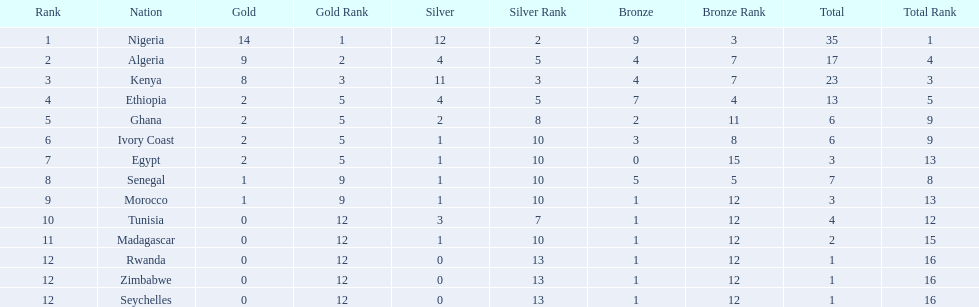What are all the nations? Nigeria, Algeria, Kenya, Ethiopia, Ghana, Ivory Coast, Egypt, Senegal, Morocco, Tunisia, Madagascar, Rwanda, Zimbabwe, Seychelles. How many bronze medals did they win? 9, 4, 4, 7, 2, 3, 0, 5, 1, 1, 1, 1, 1, 1. And which nation did not win one? Egypt. Can you give me this table in json format? {'header': ['Rank', 'Nation', 'Gold', 'Gold Rank', 'Silver', 'Silver Rank', 'Bronze', 'Bronze Rank', 'Total', 'Total Rank'], 'rows': [['1', 'Nigeria', '14', '1', '12', '2', '9', '3', '35', '1'], ['2', 'Algeria', '9', '2', '4', '5', '4', '7', '17', '4'], ['3', 'Kenya', '8', '3', '11', '3', '4', '7', '23', '3'], ['4', 'Ethiopia', '2', '5', '4', '5', '7', '4', '13', '5'], ['5', 'Ghana', '2', '5', '2', '8', '2', '11', '6', '9'], ['6', 'Ivory Coast', '2', '5', '1', '10', '3', '8', '6', '9'], ['7', 'Egypt', '2', '5', '1', '10', '0', '15', '3', '13'], ['8', 'Senegal', '1', '9', '1', '10', '5', '5', '7', '8'], ['9', 'Morocco', '1', '9', '1', '10', '1', '12', '3', '13'], ['10', 'Tunisia', '0', '12', '3', '7', '1', '12', '4', '12'], ['11', 'Madagascar', '0', '12', '1', '10', '1', '12', '2', '15'], ['12', 'Rwanda', '0', '12', '0', '13', '1', '12', '1', '16'], ['12', 'Zimbabwe', '0', '12', '0', '13', '1', '12', '1', '16'], ['12', 'Seychelles', '0', '12', '0', '13', '1', '12', '1', '16']]} 